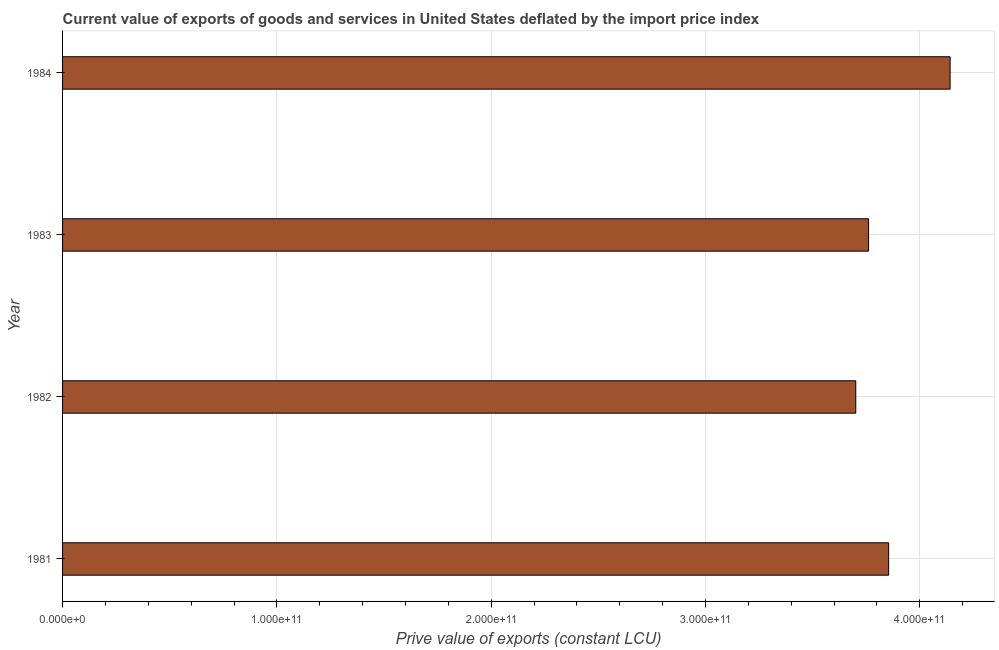Does the graph contain any zero values?
Make the answer very short. No. What is the title of the graph?
Your answer should be very brief. Current value of exports of goods and services in United States deflated by the import price index. What is the label or title of the X-axis?
Provide a short and direct response. Prive value of exports (constant LCU). What is the label or title of the Y-axis?
Your response must be concise. Year. What is the price value of exports in 1984?
Your answer should be compact. 4.14e+11. Across all years, what is the maximum price value of exports?
Offer a very short reply. 4.14e+11. Across all years, what is the minimum price value of exports?
Provide a succinct answer. 3.70e+11. What is the sum of the price value of exports?
Ensure brevity in your answer.  1.55e+12. What is the difference between the price value of exports in 1983 and 1984?
Keep it short and to the point. -3.80e+1. What is the average price value of exports per year?
Keep it short and to the point. 3.86e+11. What is the median price value of exports?
Your response must be concise. 3.81e+11. Do a majority of the years between 1984 and 1981 (inclusive) have price value of exports greater than 20000000000 LCU?
Make the answer very short. Yes. Is the difference between the price value of exports in 1982 and 1984 greater than the difference between any two years?
Give a very brief answer. Yes. What is the difference between the highest and the second highest price value of exports?
Ensure brevity in your answer.  2.87e+1. What is the difference between the highest and the lowest price value of exports?
Make the answer very short. 4.40e+1. In how many years, is the price value of exports greater than the average price value of exports taken over all years?
Make the answer very short. 1. What is the difference between two consecutive major ticks on the X-axis?
Give a very brief answer. 1.00e+11. What is the Prive value of exports (constant LCU) in 1981?
Keep it short and to the point. 3.85e+11. What is the Prive value of exports (constant LCU) of 1982?
Provide a short and direct response. 3.70e+11. What is the Prive value of exports (constant LCU) of 1983?
Keep it short and to the point. 3.76e+11. What is the Prive value of exports (constant LCU) of 1984?
Make the answer very short. 4.14e+11. What is the difference between the Prive value of exports (constant LCU) in 1981 and 1982?
Your response must be concise. 1.53e+1. What is the difference between the Prive value of exports (constant LCU) in 1981 and 1983?
Keep it short and to the point. 9.37e+09. What is the difference between the Prive value of exports (constant LCU) in 1981 and 1984?
Your answer should be compact. -2.87e+1. What is the difference between the Prive value of exports (constant LCU) in 1982 and 1983?
Provide a short and direct response. -5.98e+09. What is the difference between the Prive value of exports (constant LCU) in 1982 and 1984?
Your answer should be very brief. -4.40e+1. What is the difference between the Prive value of exports (constant LCU) in 1983 and 1984?
Your answer should be very brief. -3.80e+1. What is the ratio of the Prive value of exports (constant LCU) in 1981 to that in 1982?
Offer a very short reply. 1.04. What is the ratio of the Prive value of exports (constant LCU) in 1981 to that in 1983?
Provide a short and direct response. 1.02. What is the ratio of the Prive value of exports (constant LCU) in 1981 to that in 1984?
Offer a very short reply. 0.93. What is the ratio of the Prive value of exports (constant LCU) in 1982 to that in 1984?
Make the answer very short. 0.89. What is the ratio of the Prive value of exports (constant LCU) in 1983 to that in 1984?
Offer a very short reply. 0.91. 